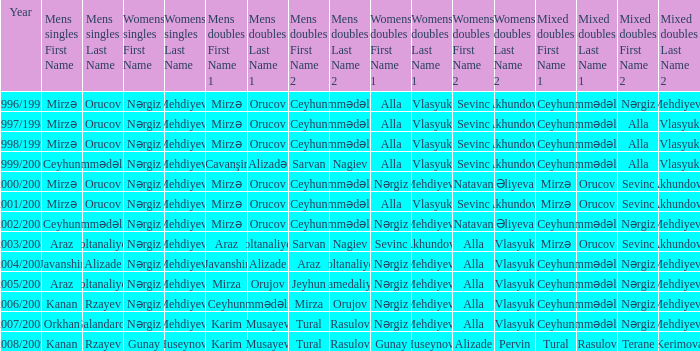Who were all womens doubles for the year 2000/2001? Nərgiz Mehdiyeva Natavan Əliyeva. 